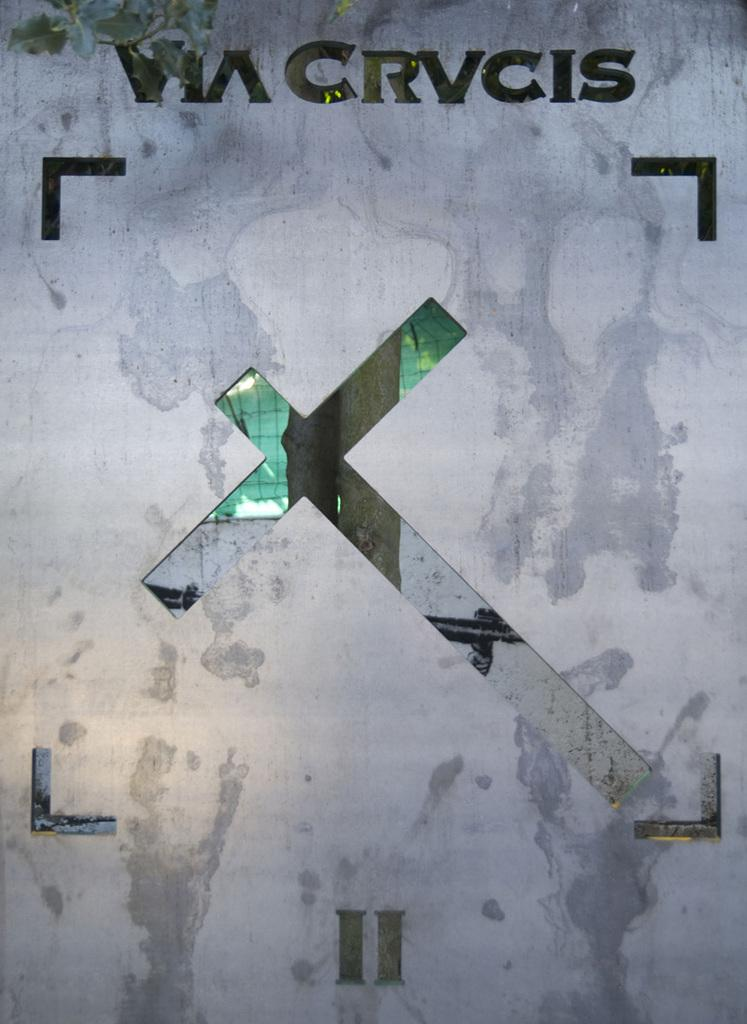<image>
Create a compact narrative representing the image presented. Words on a wall that say "Via CRVCIS" with a cross right under. 